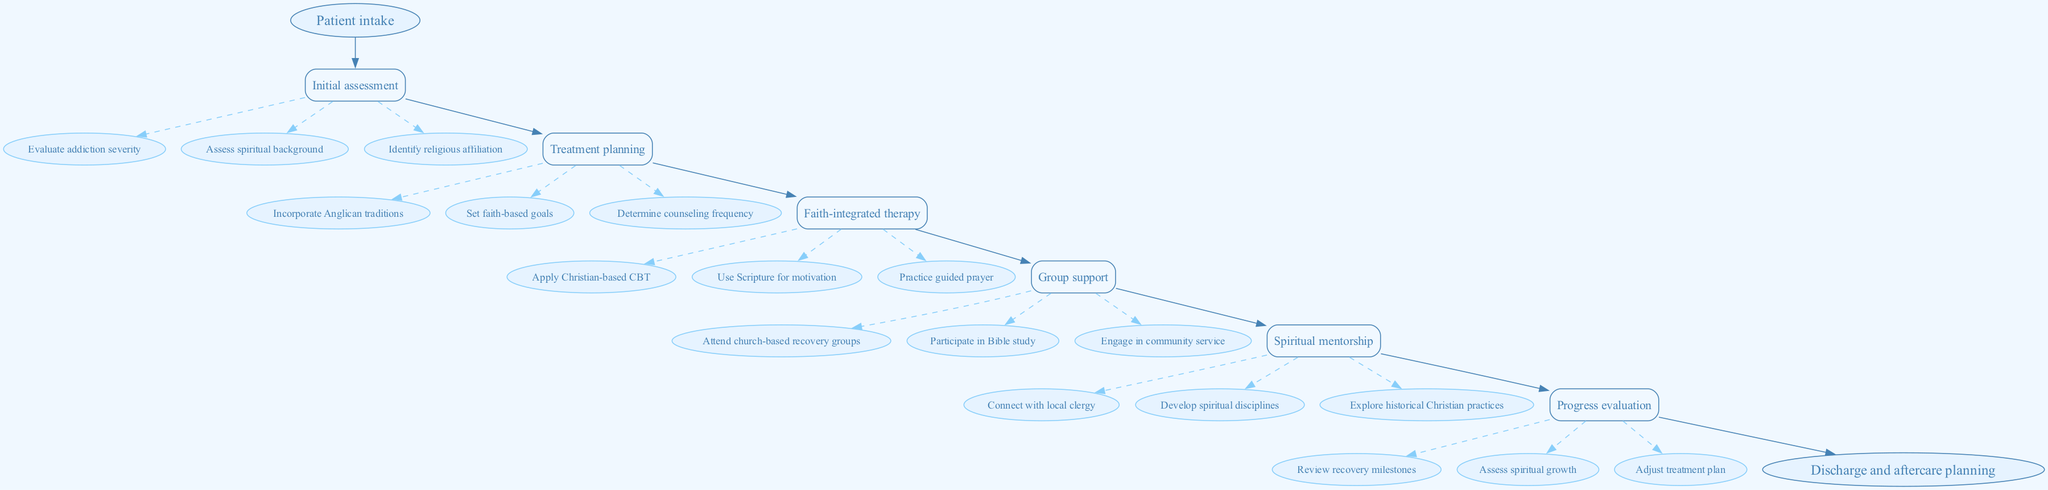What is the first step in the clinical pathway? The first step node is labeled "Initial assessment," which follows the starting point "Patient intake." This indicates that upon intake, the first action taken is conducting an initial assessment.
Answer: Initial assessment How many steps are there in the clinical pathway? By counting the nodes used for each step, we find there are six steps listed in the diagram: Initial assessment, Treatment planning, Faith-integrated therapy, Group support, Spiritual mentorship, and Progress evaluation.
Answer: 6 What task is associated with "Spiritual mentorship"? Looking at the tasks grouped under the "Spiritual mentorship" step, one task mentioned is "Connect with local clergy." This is a specific task outlined in this section of the pathway.
Answer: Connect with local clergy What is the last step before discharge? The last step just before reaching the discharge and aftercare planning node is "Progress evaluation," which indicates that evaluations of progress are conducted immediately prior to discharge.
Answer: Progress evaluation Name one faith-based goal that might be set in treatment planning. The "Treatment planning" section includes a task for "Set faith-based goals." This core task reflects the emphasis on spiritual and religious integration in recovery.
Answer: Set faith-based goals Which step involves the application of Scripture for motivation? The relevant step labeled "Faith-integrated therapy" includes the task "Use Scripture for motivation." This indicates that Scripture is referenced in therapy to motivate patients.
Answer: Use Scripture for motivation What type of therapy is mentioned in this clinical pathway? Under the "Faith-integrated therapy" step, the type of therapy mentioned is "Christian-based CBT." This indicates a specific counseling approach used within this pathway.
Answer: Christian-based CBT Which task encourages participation in community service? In the "Group support" step, one of the tasks is "Engage in community service." This highlights the importance of community involvement as part of the recovery process.
Answer: Engage in community service What is the purpose of "Progress evaluation"? The main purpose outlined for "Progress evaluation" includes reviewing recovery milestones and assessing spiritual growth, which is essential for adjusting the treatment plan effectively.
Answer: Review recovery milestones 